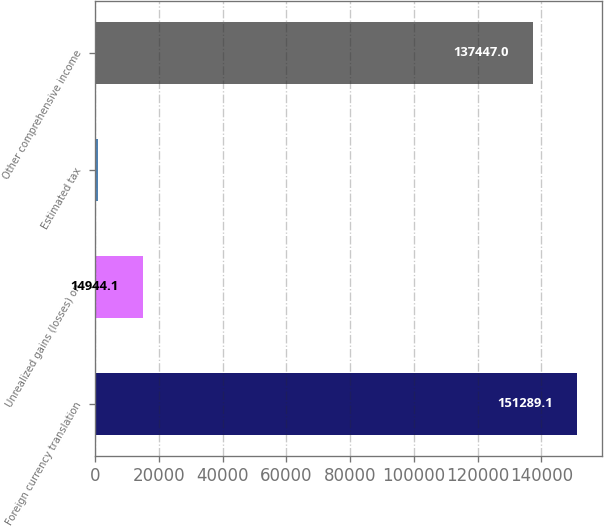Convert chart. <chart><loc_0><loc_0><loc_500><loc_500><bar_chart><fcel>Foreign currency translation<fcel>Unrealized gains (losses) on<fcel>Estimated tax<fcel>Other comprehensive income<nl><fcel>151289<fcel>14944.1<fcel>1102<fcel>137447<nl></chart> 